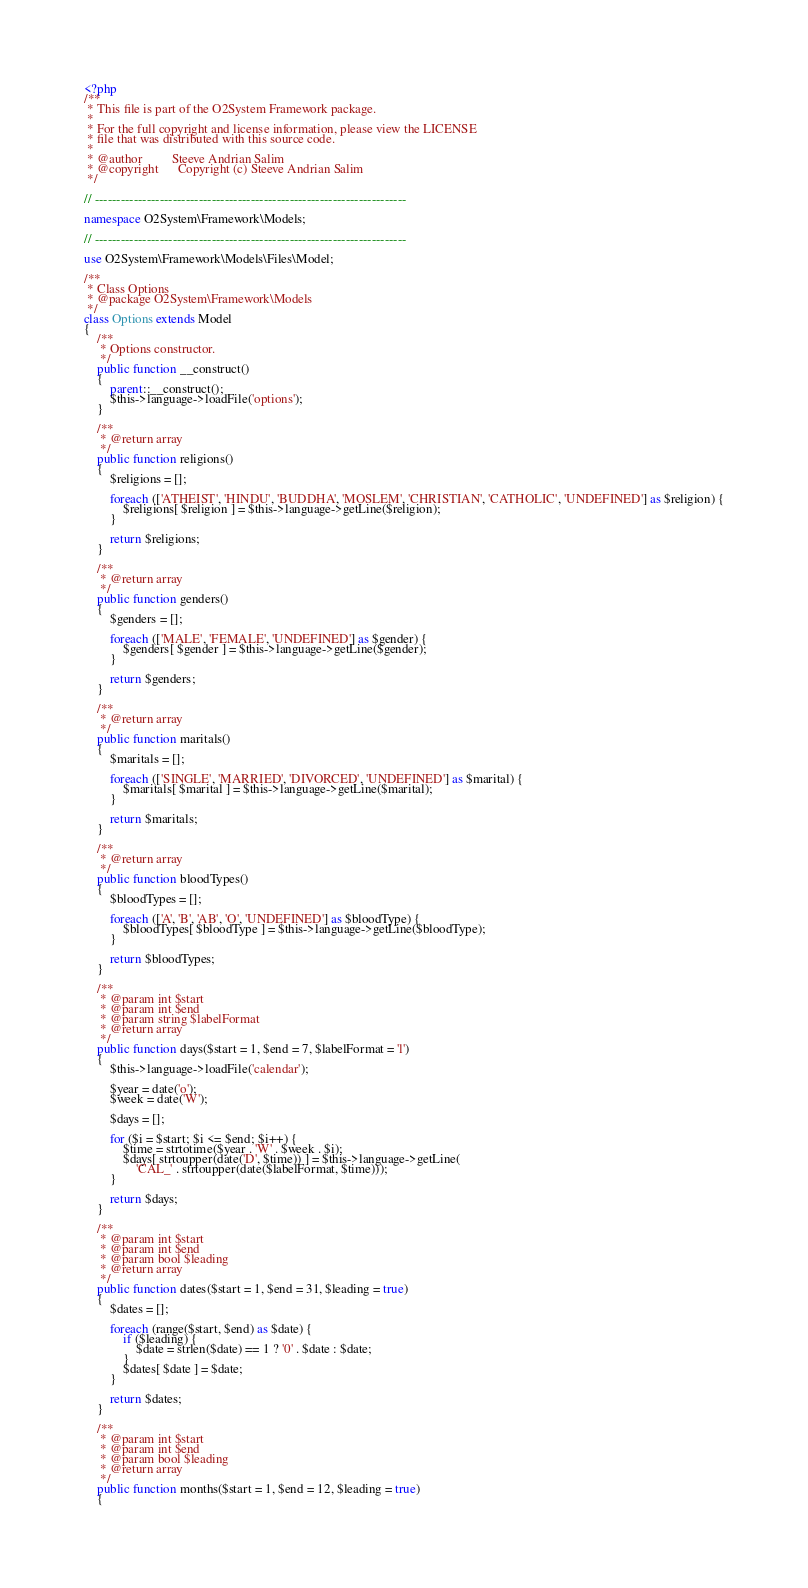Convert code to text. <code><loc_0><loc_0><loc_500><loc_500><_PHP_><?php
/**
 * This file is part of the O2System Framework package.
 *
 * For the full copyright and license information, please view the LICENSE
 * file that was distributed with this source code.
 *
 * @author         Steeve Andrian Salim
 * @copyright      Copyright (c) Steeve Andrian Salim
 */

// ------------------------------------------------------------------------

namespace O2System\Framework\Models;

// ------------------------------------------------------------------------

use O2System\Framework\Models\Files\Model;

/**
 * Class Options
 * @package O2System\Framework\Models
 */
class Options extends Model
{
    /**
     * Options constructor.
     */
    public function __construct()
    {
        parent::__construct();
        $this->language->loadFile('options');
    }

    /**
     * @return array
     */
    public function religions()
    {
        $religions = [];

        foreach (['ATHEIST', 'HINDU', 'BUDDHA', 'MOSLEM', 'CHRISTIAN', 'CATHOLIC', 'UNDEFINED'] as $religion) {
            $religions[ $religion ] = $this->language->getLine($religion);
        }

        return $religions;
    }

    /**
     * @return array
     */
    public function genders()
    {
        $genders = [];

        foreach (['MALE', 'FEMALE', 'UNDEFINED'] as $gender) {
            $genders[ $gender ] = $this->language->getLine($gender);
        }

        return $genders;
    }

    /**
     * @return array
     */
    public function maritals()
    {
        $maritals = [];

        foreach (['SINGLE', 'MARRIED', 'DIVORCED', 'UNDEFINED'] as $marital) {
            $maritals[ $marital ] = $this->language->getLine($marital);
        }

        return $maritals;
    }

    /**
     * @return array
     */
    public function bloodTypes()
    {
        $bloodTypes = [];

        foreach (['A', 'B', 'AB', 'O', 'UNDEFINED'] as $bloodType) {
            $bloodTypes[ $bloodType ] = $this->language->getLine($bloodType);
        }

        return $bloodTypes;
    }

    /**
     * @param int $start
     * @param int $end
     * @param string $labelFormat
     * @return array
     */
    public function days($start = 1, $end = 7, $labelFormat = 'l')
    {
        $this->language->loadFile('calendar');

        $year = date('o');
        $week = date('W');

        $days = [];

        for ($i = $start; $i <= $end; $i++) {
            $time = strtotime($year . 'W' . $week . $i);
            $days[ strtoupper(date('D', $time)) ] = $this->language->getLine(
                'CAL_' . strtoupper(date($labelFormat, $time)));
        }

        return $days;
    }

    /**
     * @param int $start
     * @param int $end
     * @param bool $leading
     * @return array
     */
    public function dates($start = 1, $end = 31, $leading = true)
    {
        $dates = [];

        foreach (range($start, $end) as $date) {
            if ($leading) {
                $date = strlen($date) == 1 ? '0' . $date : $date;
            }
            $dates[ $date ] = $date;
        }

        return $dates;
    }

    /**
     * @param int $start
     * @param int $end
     * @param bool $leading
     * @return array
     */
    public function months($start = 1, $end = 12, $leading = true)
    {</code> 